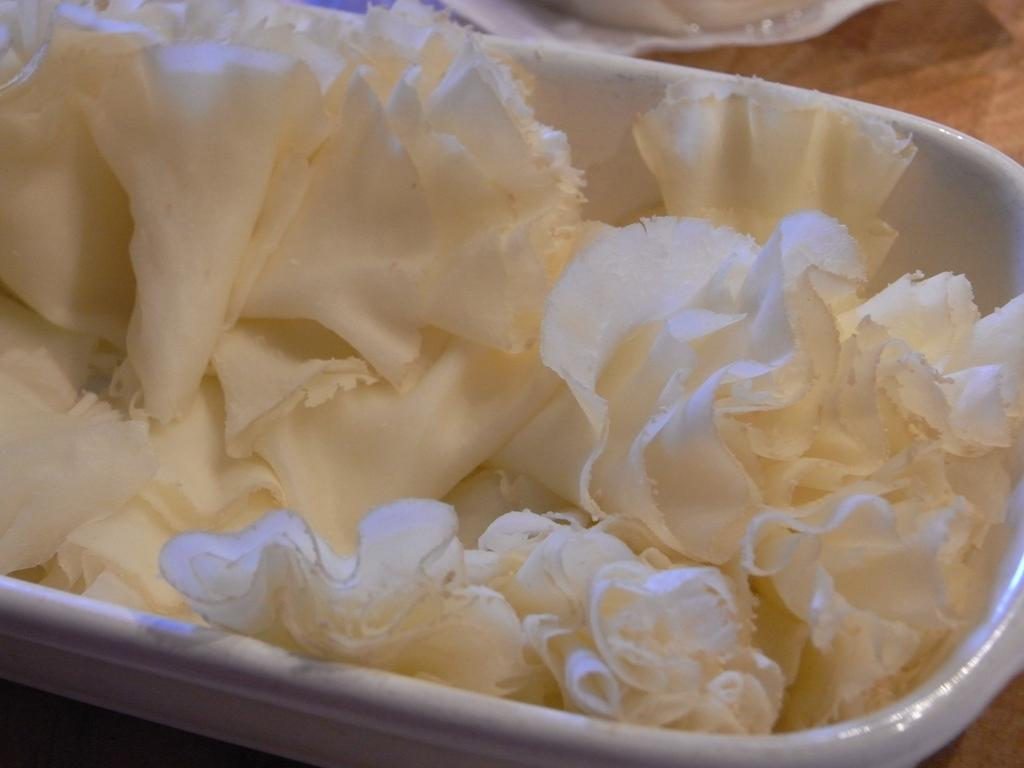What is located in the center of the image? There is a bowl in the center of the image. What is inside the bowl? The bowl contains flowers. Can you describe the background of the image? There are objects in the background of the image. What direction are the pets facing in the image? There are no pets present in the image. 